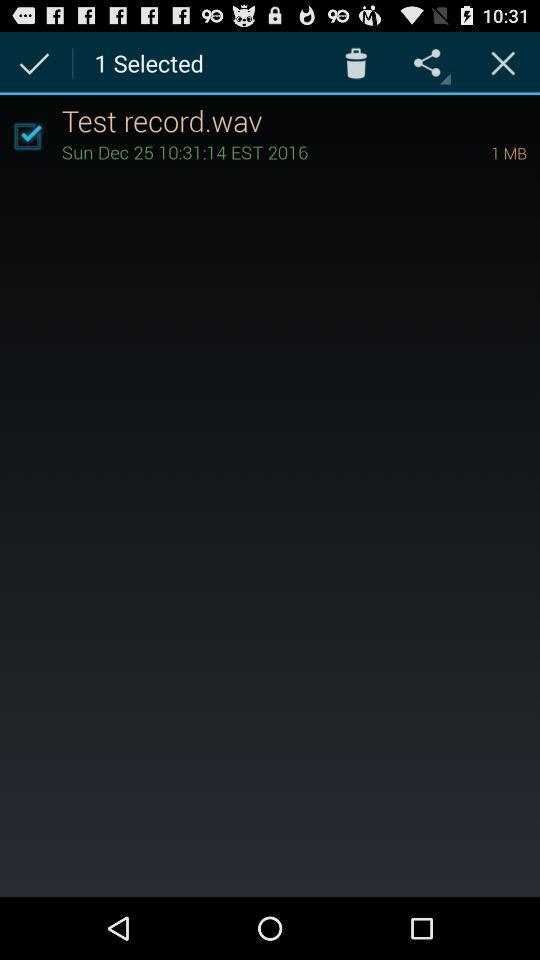Is "Test record.wav" selected or not? "Test record.wav" is selected. 